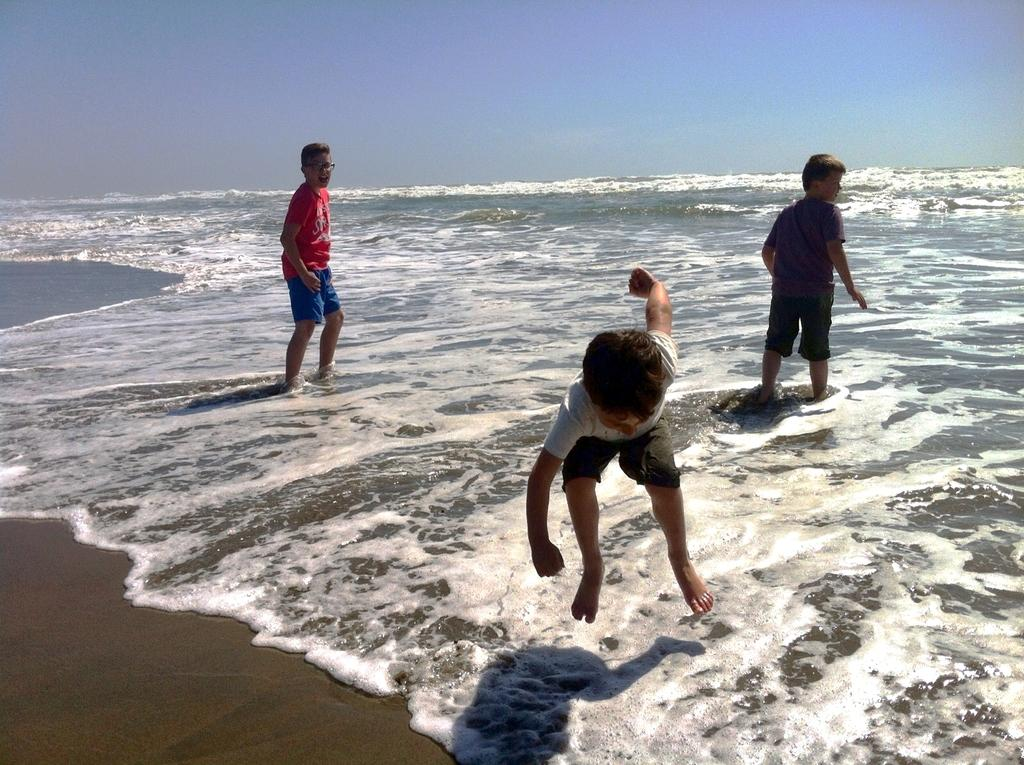How many kids are present in the image? There are three kids in the image. What are the kids doing in the image? The kids are playing on a sea shore. Can you describe the actions of the kids in the image? One kid is jumping in the center of the image, while the other two kids are standing. What is visible at the top of the image? The sky is visible at the top of the image. What type of brake can be seen on the kids' bicycles in the image? There are no bicycles or brakes present in the image; the kids are playing on a sea shore. What is the tendency of the cap in the image? There is no cap present in the image, so it is not possible to determine its tendency. 